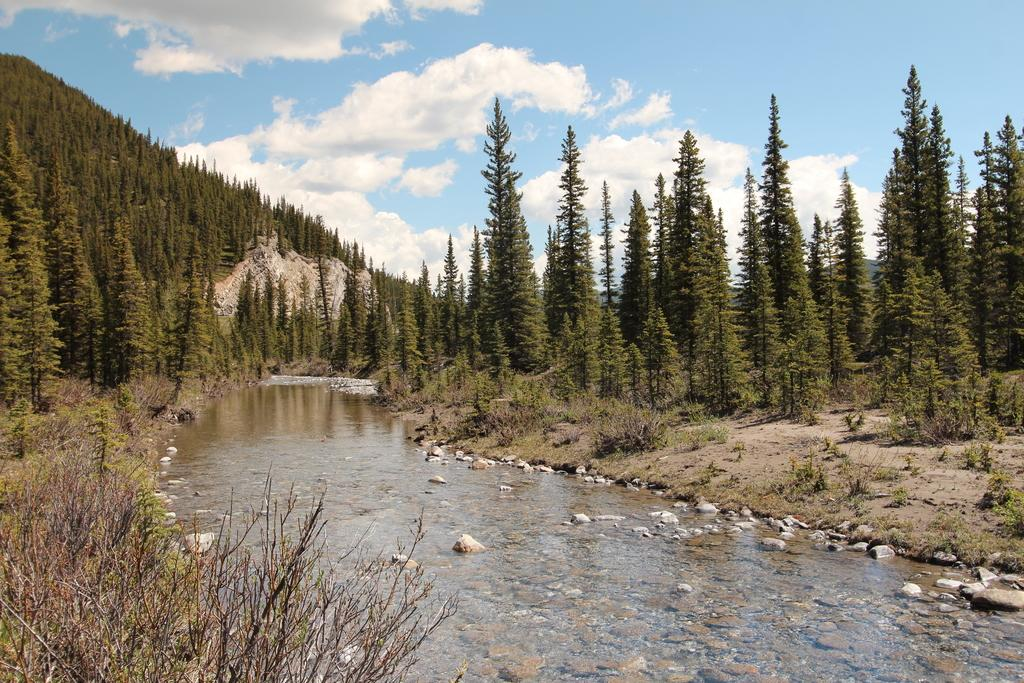What is in the water in the image? There are stones in the water in the image. What type of vegetation can be seen in the image? There are trees and plants in the image. What geographical feature is covered with trees in the image? There are mountains covered with trees in the image. What is visible in the sky in the image? There are clouds in the sky in the image. Where is the sofa located in the image? There is no sofa present in the image. Who is the guide in the image? There is no guide present in the image. 